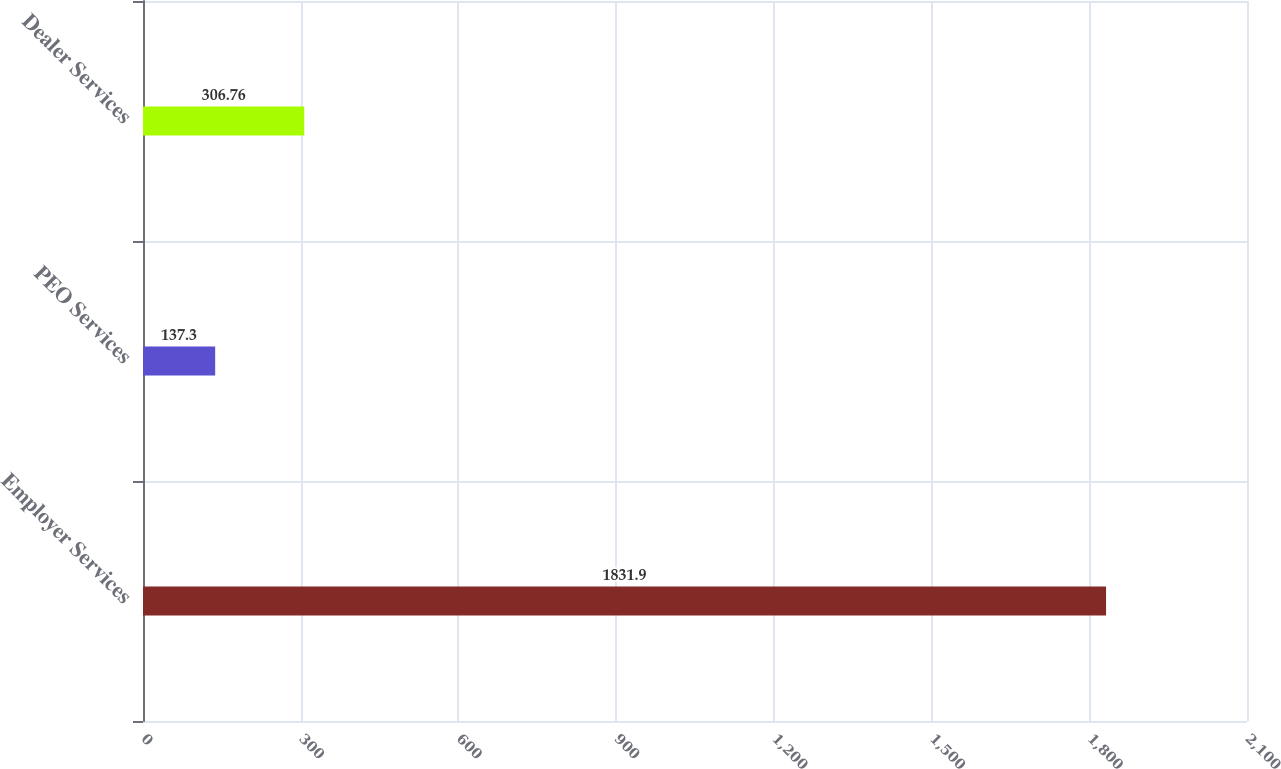Convert chart to OTSL. <chart><loc_0><loc_0><loc_500><loc_500><bar_chart><fcel>Employer Services<fcel>PEO Services<fcel>Dealer Services<nl><fcel>1831.9<fcel>137.3<fcel>306.76<nl></chart> 